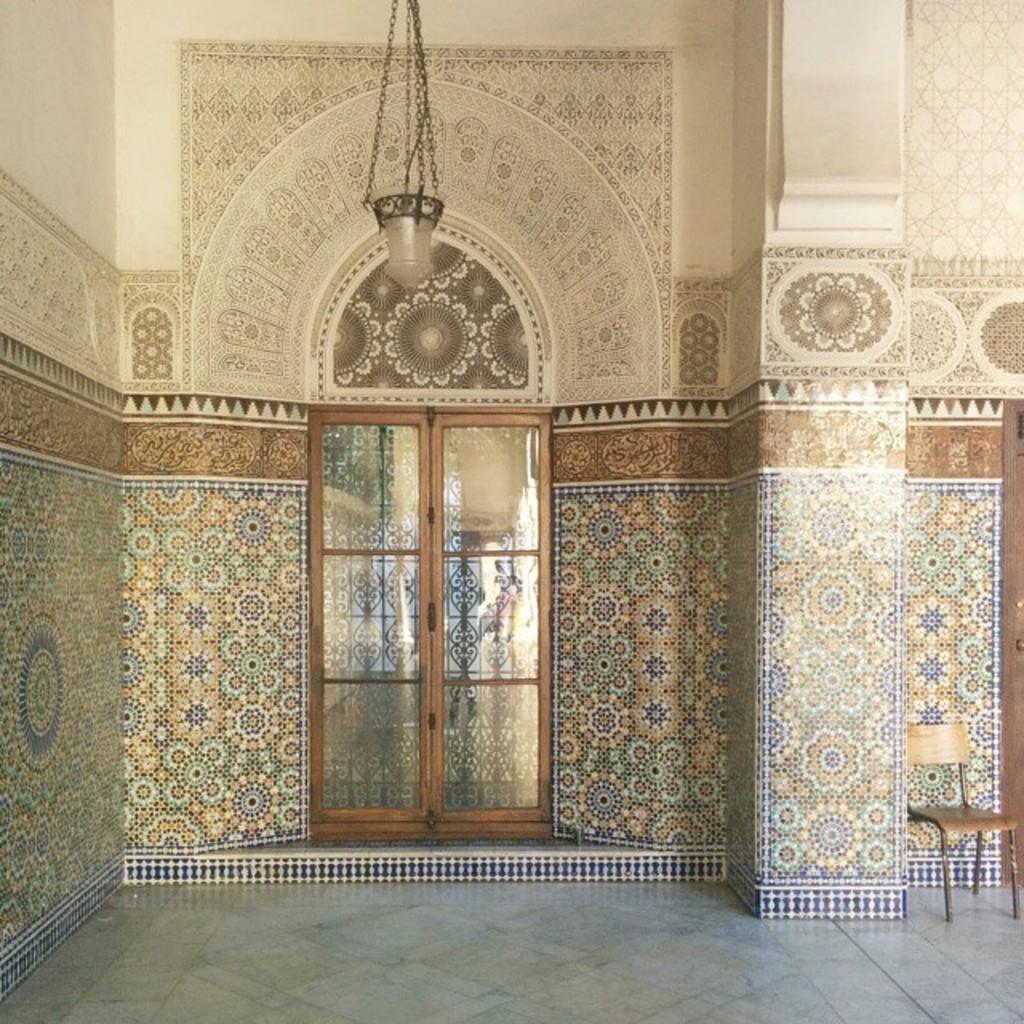In one or two sentences, can you explain what this image depicts? In this image it looks like inside of the building. And there is a chair on the floor. And there is a light on the wall. 